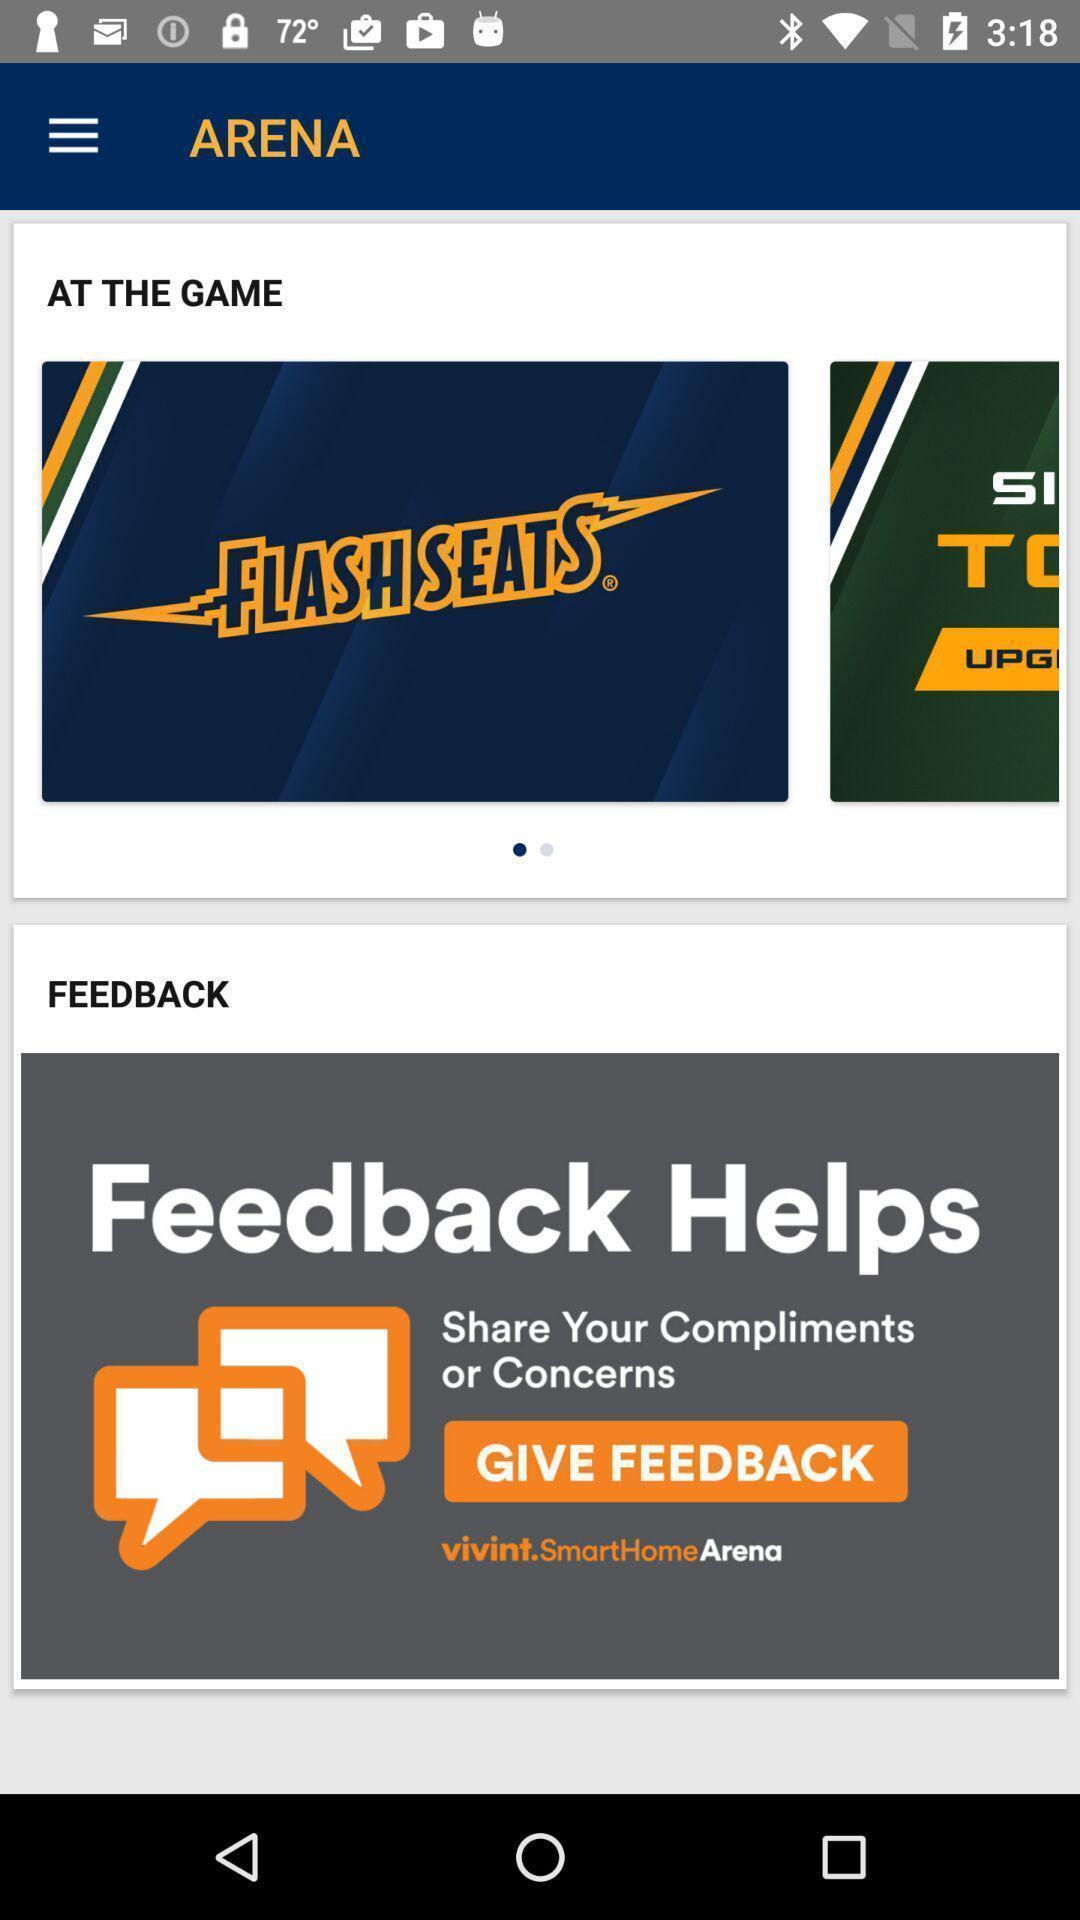Explain what's happening in this screen capture. Screen showing at the game. 